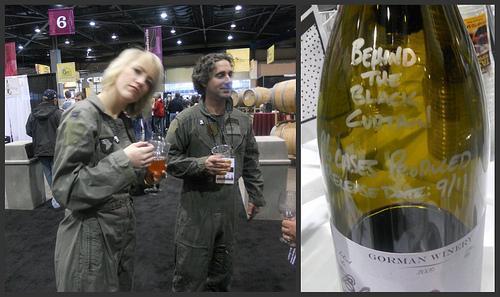How many people are in the foreground of the photo?
Give a very brief answer. 2. 